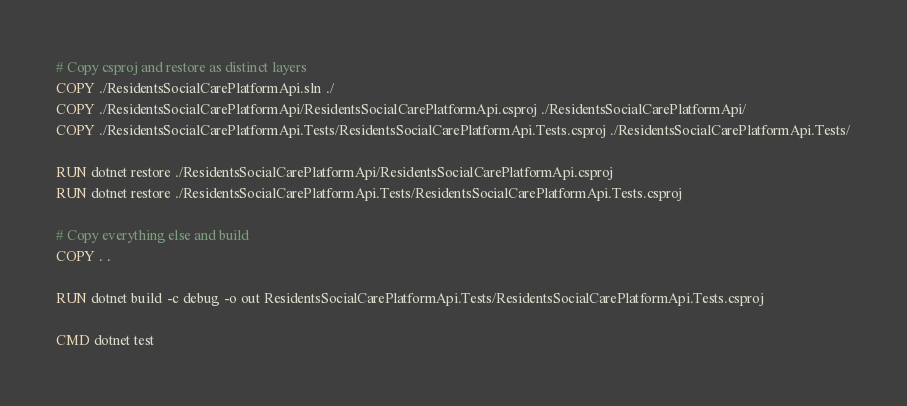Convert code to text. <code><loc_0><loc_0><loc_500><loc_500><_Dockerfile_># Copy csproj and restore as distinct layers
COPY ./ResidentsSocialCarePlatformApi.sln ./
COPY ./ResidentsSocialCarePlatformApi/ResidentsSocialCarePlatformApi.csproj ./ResidentsSocialCarePlatformApi/
COPY ./ResidentsSocialCarePlatformApi.Tests/ResidentsSocialCarePlatformApi.Tests.csproj ./ResidentsSocialCarePlatformApi.Tests/

RUN dotnet restore ./ResidentsSocialCarePlatformApi/ResidentsSocialCarePlatformApi.csproj
RUN dotnet restore ./ResidentsSocialCarePlatformApi.Tests/ResidentsSocialCarePlatformApi.Tests.csproj

# Copy everything else and build
COPY . .

RUN dotnet build -c debug -o out ResidentsSocialCarePlatformApi.Tests/ResidentsSocialCarePlatformApi.Tests.csproj

CMD dotnet test
</code> 